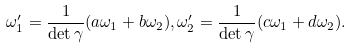Convert formula to latex. <formula><loc_0><loc_0><loc_500><loc_500>\omega _ { 1 } ^ { \prime } = \frac { 1 } { \det \gamma } ( a \omega _ { 1 } + b \omega _ { 2 } ) , \omega _ { 2 } ^ { \prime } = \frac { 1 } { \det \gamma } ( c \omega _ { 1 } + d \omega _ { 2 } ) .</formula> 